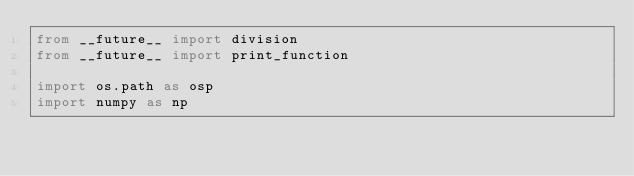<code> <loc_0><loc_0><loc_500><loc_500><_Python_>from __future__ import division
from __future__ import print_function

import os.path as osp
import numpy as np</code> 